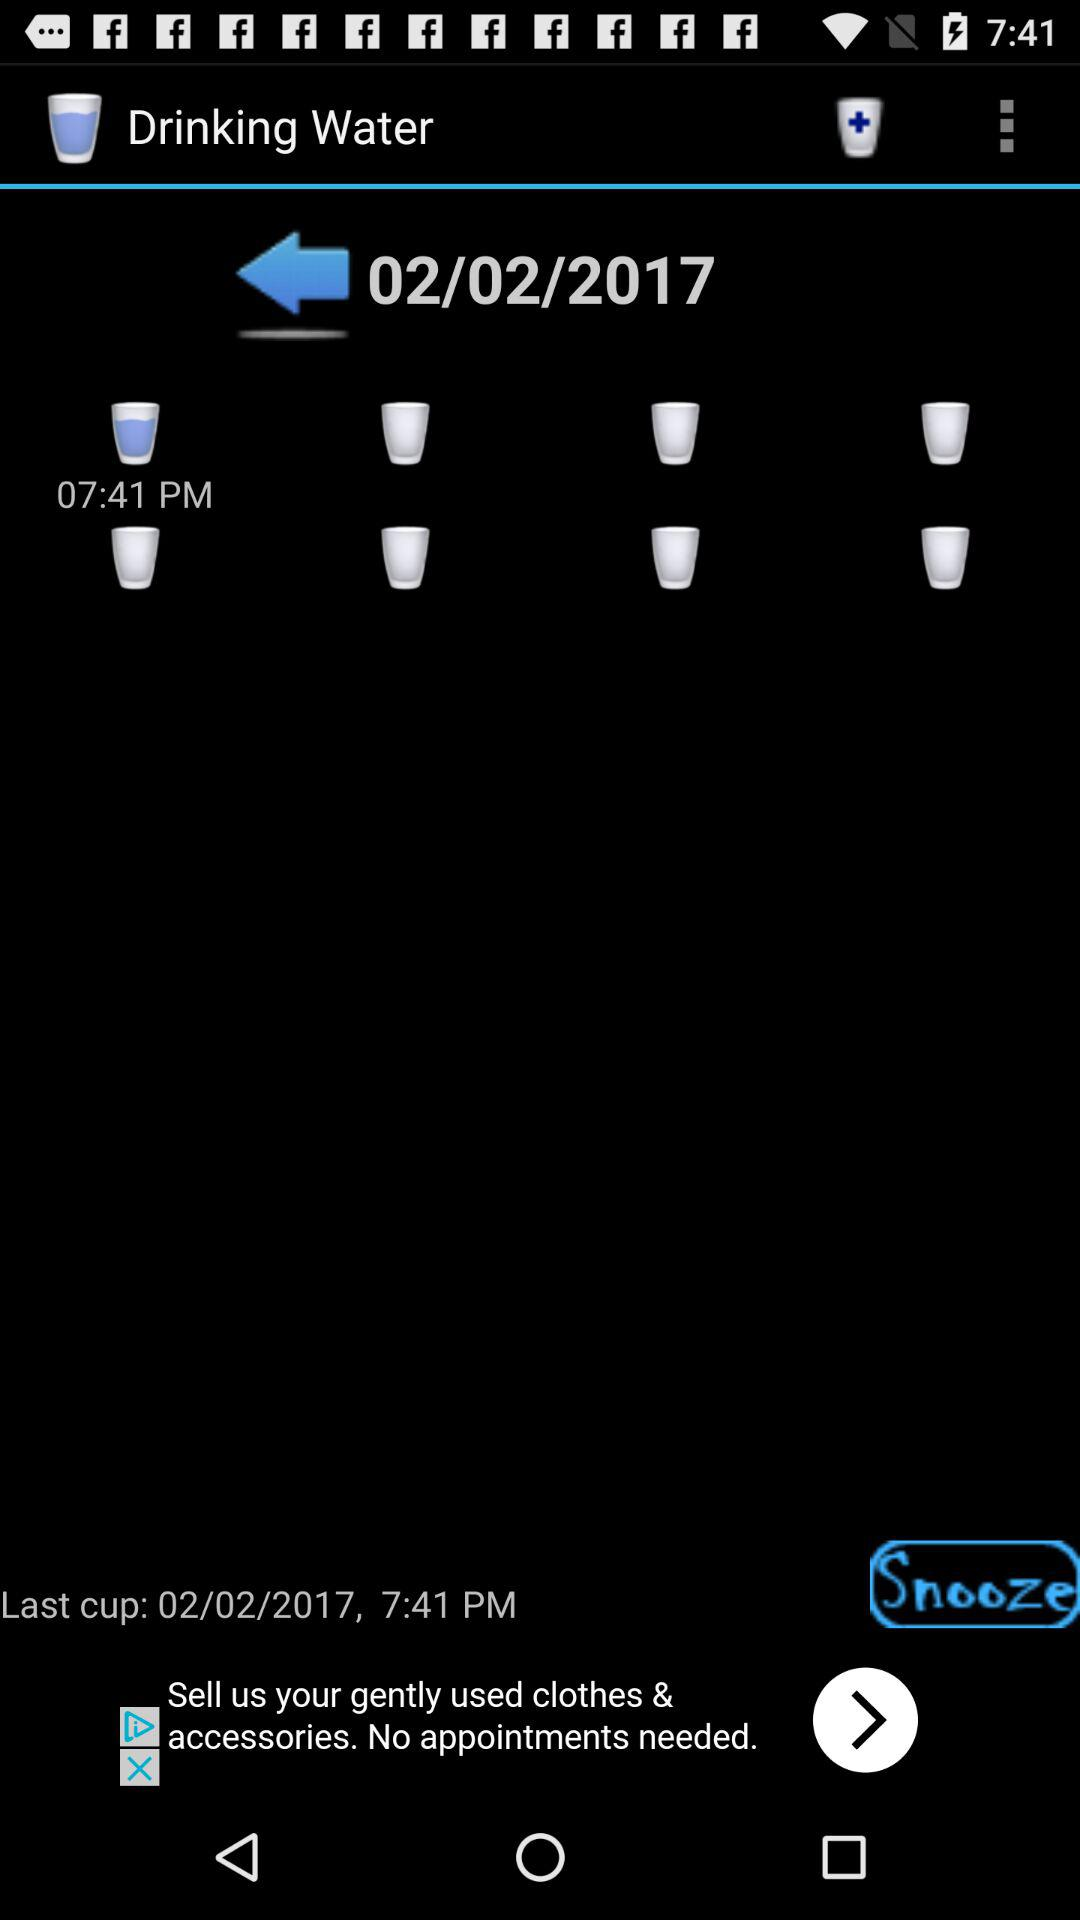How much water in ounces has been drunk?
When the provided information is insufficient, respond with <no answer>. <no answer> 